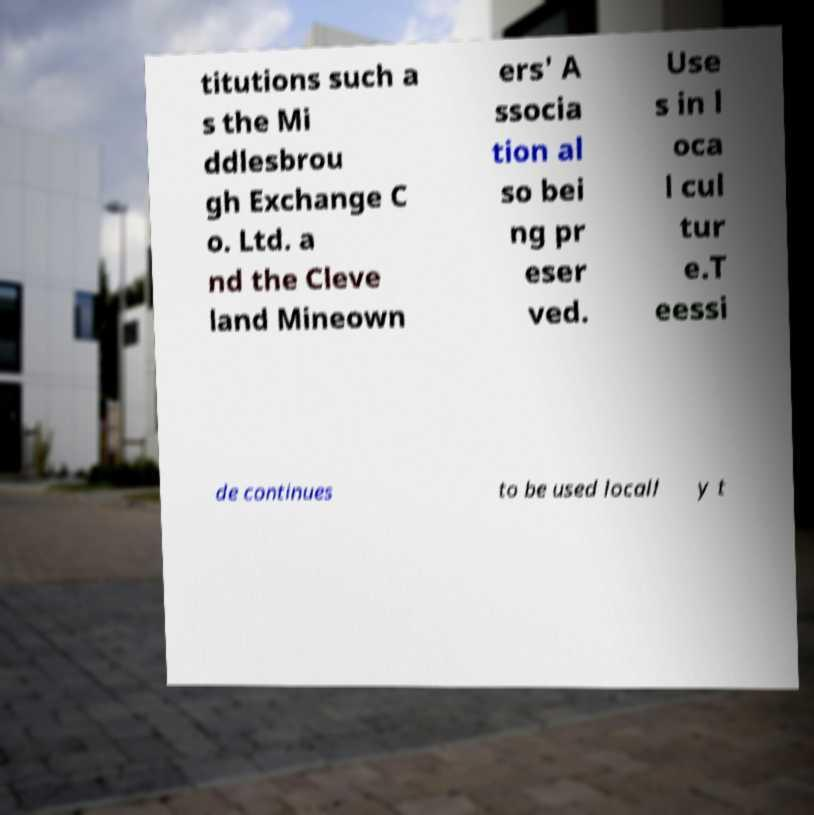Could you extract and type out the text from this image? titutions such a s the Mi ddlesbrou gh Exchange C o. Ltd. a nd the Cleve land Mineown ers' A ssocia tion al so bei ng pr eser ved. Use s in l oca l cul tur e.T eessi de continues to be used locall y t 